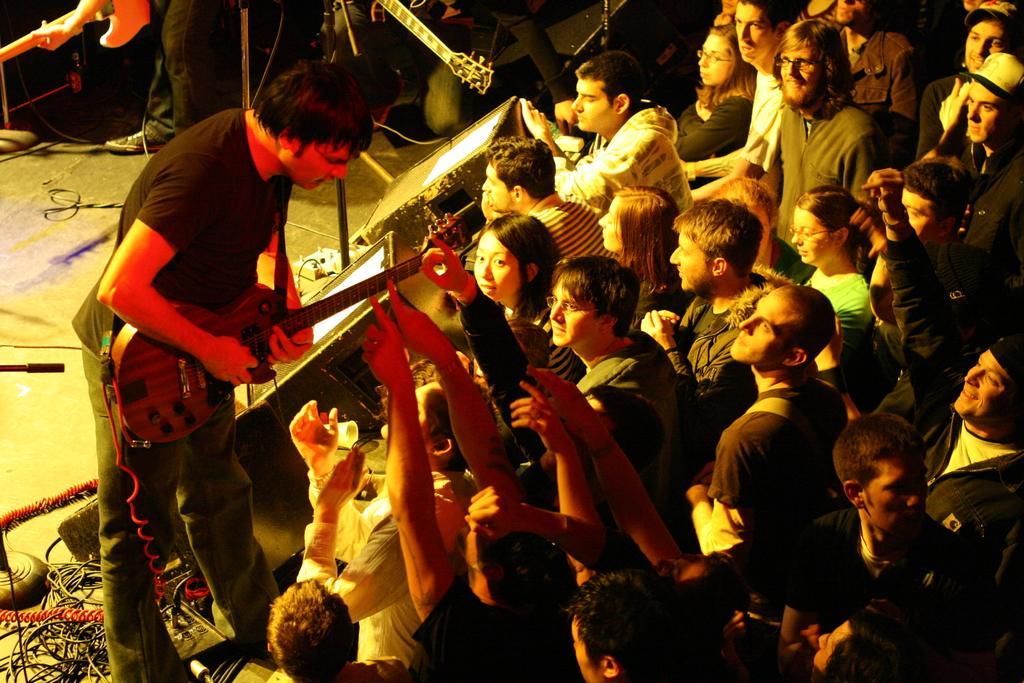How would you summarize this image in a sentence or two? In this picture towards right there are audience cheering and towards left it is stage, on the stage there is a band. On the left there is a person playing guitar and there are cables, mic. At the top there are two people playing guitar and there is a mic. 